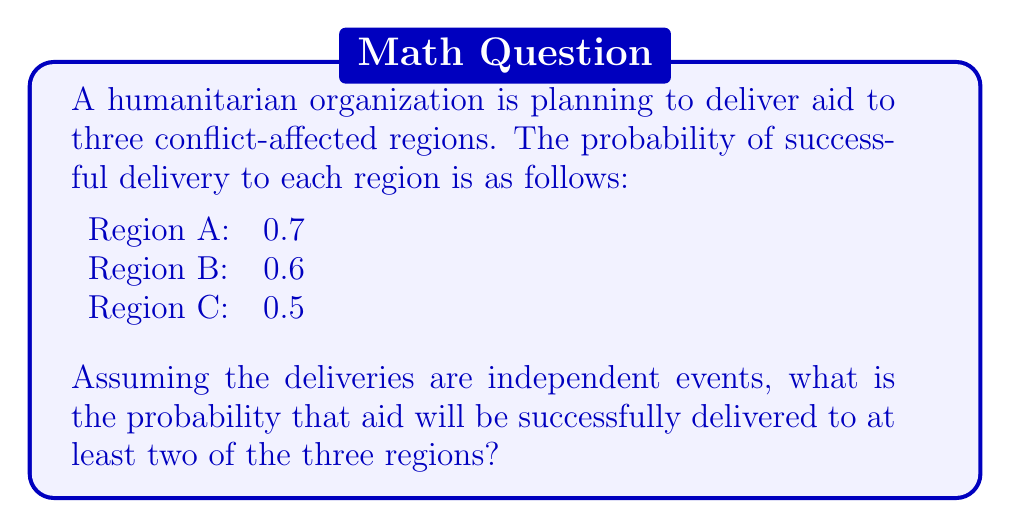Show me your answer to this math problem. To solve this problem, we need to use the concept of probability for multiple independent events. Let's approach this step-by-step:

1) First, let's define our events:
   A: Successful delivery to Region A
   B: Successful delivery to Region B
   C: Successful delivery to Region C

2) We need to find P(at least two successful deliveries). This is equivalent to:
   P(all three successful) + P(exactly two successful)

3) P(all three successful) = P(A) × P(B) × P(C)
   $$ P(\text{all three}) = 0.7 \times 0.6 \times 0.5 = 0.21 $$

4) P(exactly two successful) can occur in three ways:
   - A and B succeed, C fails: P(A) × P(B) × (1 - P(C))
   - A and C succeed, B fails: P(A) × (1 - P(B)) × P(C)
   - B and C succeed, A fails: (1 - P(A)) × P(B) × P(C)

   $$ P(\text{exactly two}) = (0.7 \times 0.6 \times 0.5) + (0.7 \times 0.4 \times 0.5) + (0.3 \times 0.6 \times 0.5) $$
   $$ = 0.21 + 0.14 + 0.09 = 0.44 $$

5) Therefore, the probability of at least two successful deliveries is:
   $$ P(\text{at least two}) = P(\text{all three}) + P(\text{exactly two}) $$
   $$ = 0.21 + 0.44 = 0.65 $$
Answer: The probability that aid will be successfully delivered to at least two of the three regions is 0.65 or 65%. 